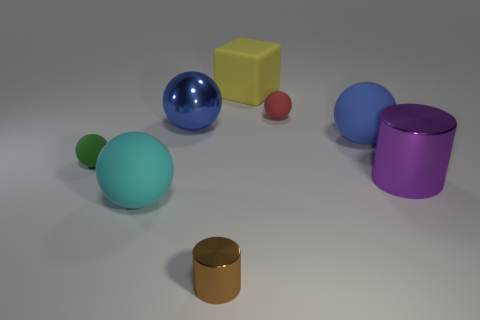What material is the tiny brown thing?
Your answer should be very brief. Metal. What size is the blue object that is made of the same material as the brown thing?
Provide a short and direct response. Large. What is the color of the big matte sphere on the left side of the shiny thing that is left of the brown cylinder?
Your response must be concise. Cyan. How many large spheres are the same material as the big yellow block?
Provide a succinct answer. 2. How many rubber things are large blue spheres or small red balls?
Give a very brief answer. 2. What material is the purple thing that is the same size as the blue shiny thing?
Provide a short and direct response. Metal. Is there a big object that has the same material as the brown cylinder?
Give a very brief answer. Yes. The big thing that is on the right side of the blue thing that is on the right side of the yellow object on the right side of the tiny brown shiny cylinder is what shape?
Your answer should be compact. Cylinder. There is a brown cylinder; does it have the same size as the cylinder behind the cyan ball?
Give a very brief answer. No. There is a tiny object that is both behind the brown thing and in front of the blue matte sphere; what is its shape?
Keep it short and to the point. Sphere. 